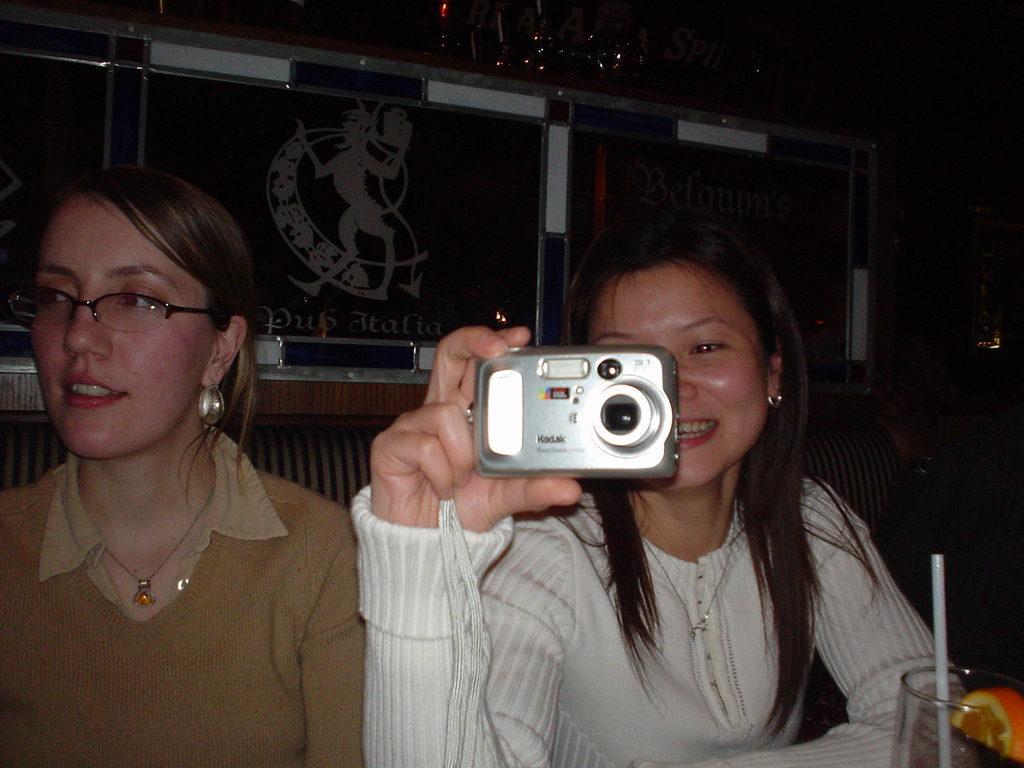Please provide a concise description of this image. This woman wore white jacket, smiling and holding a camera. Beside this woman another woman wore sweater, spectacles and smiling. In-front of this image there is a glass with straw and fruit. 